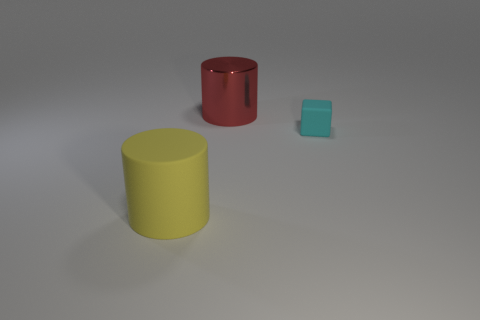Can you describe the lighting in the scene? The lighting in the image appears to be coming from above, casting soft shadows directly underneath the objects. This creates a natural and calm ambiance in the scene. 